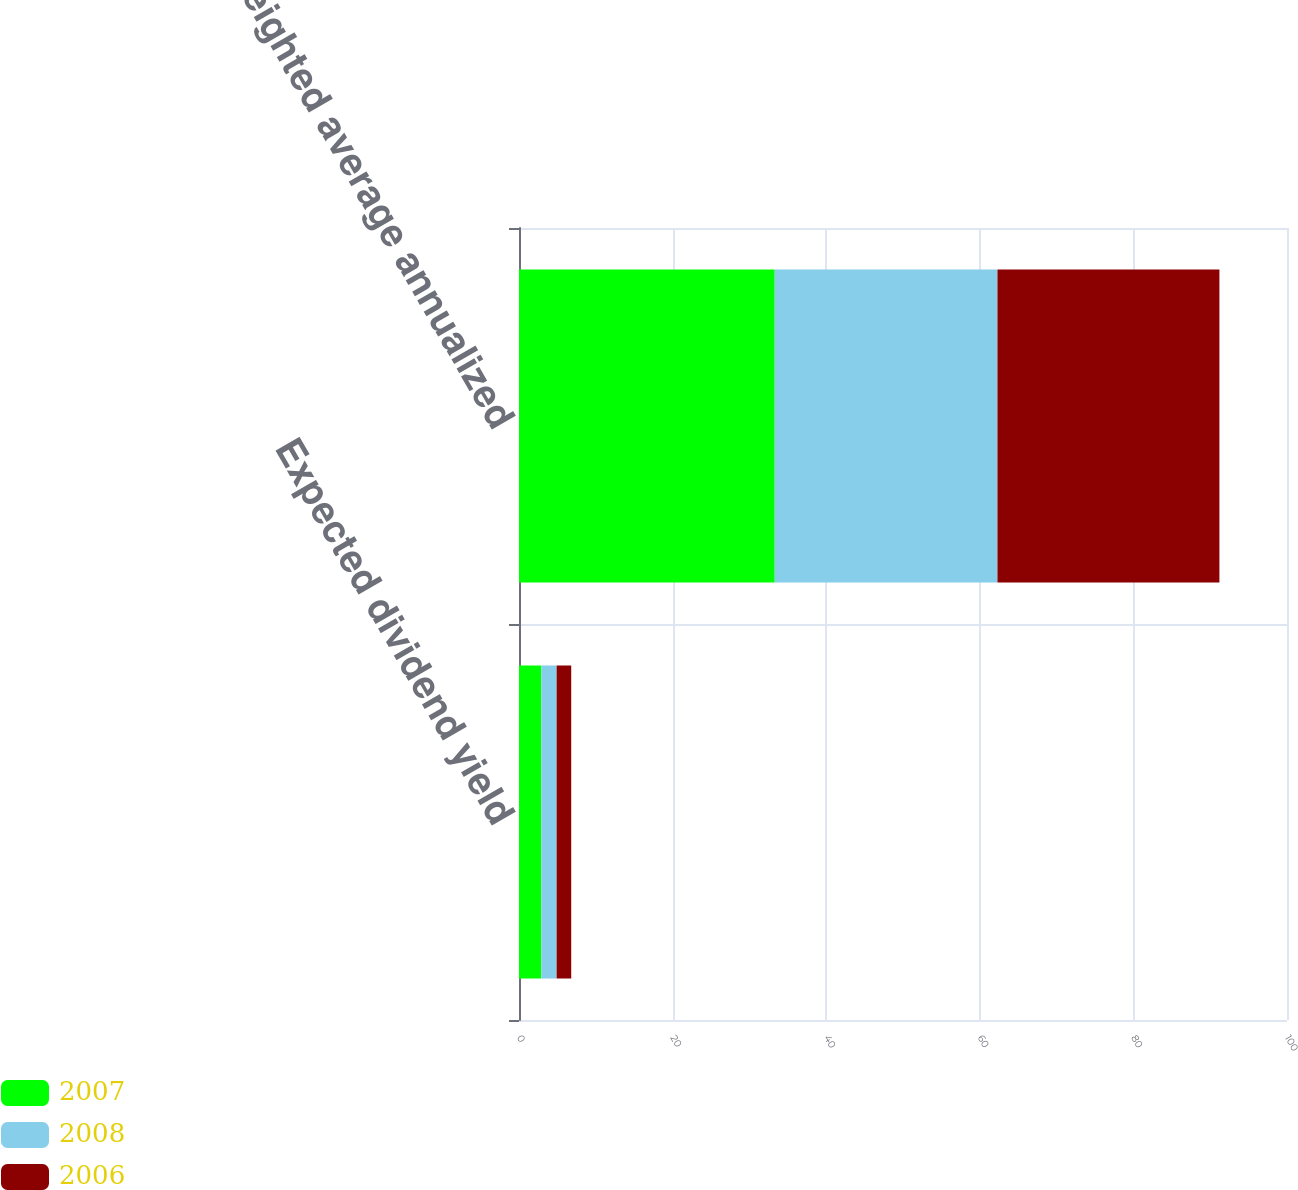Convert chart. <chart><loc_0><loc_0><loc_500><loc_500><stacked_bar_chart><ecel><fcel>Expected dividend yield<fcel>Weighted average annualized<nl><fcel>2007<fcel>2.9<fcel>33.3<nl><fcel>2008<fcel>2<fcel>29<nl><fcel>2006<fcel>1.9<fcel>28.9<nl></chart> 